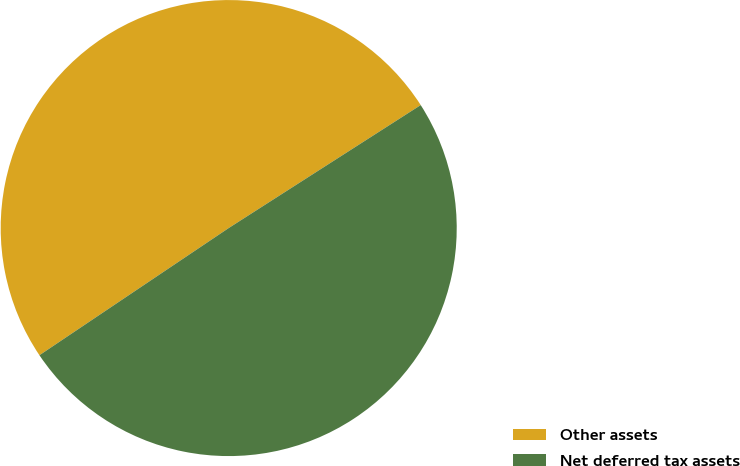Convert chart to OTSL. <chart><loc_0><loc_0><loc_500><loc_500><pie_chart><fcel>Other assets<fcel>Net deferred tax assets<nl><fcel>50.35%<fcel>49.65%<nl></chart> 